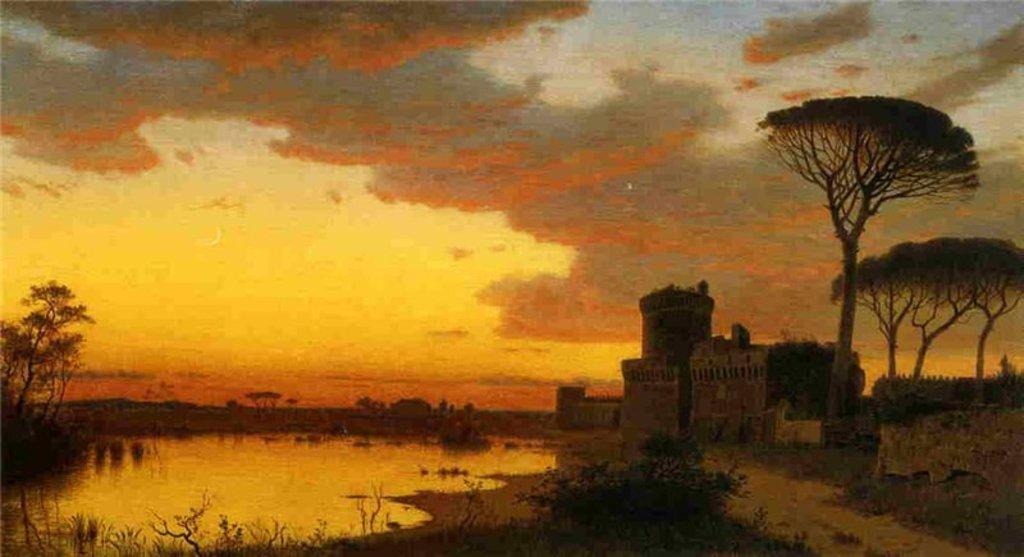Could you give a brief overview of what you see in this image? In this image we can see the house on the right side. Here we can see the trees on the left side and the right side as well. Here we can see the pond. This is a sky with clouds. 